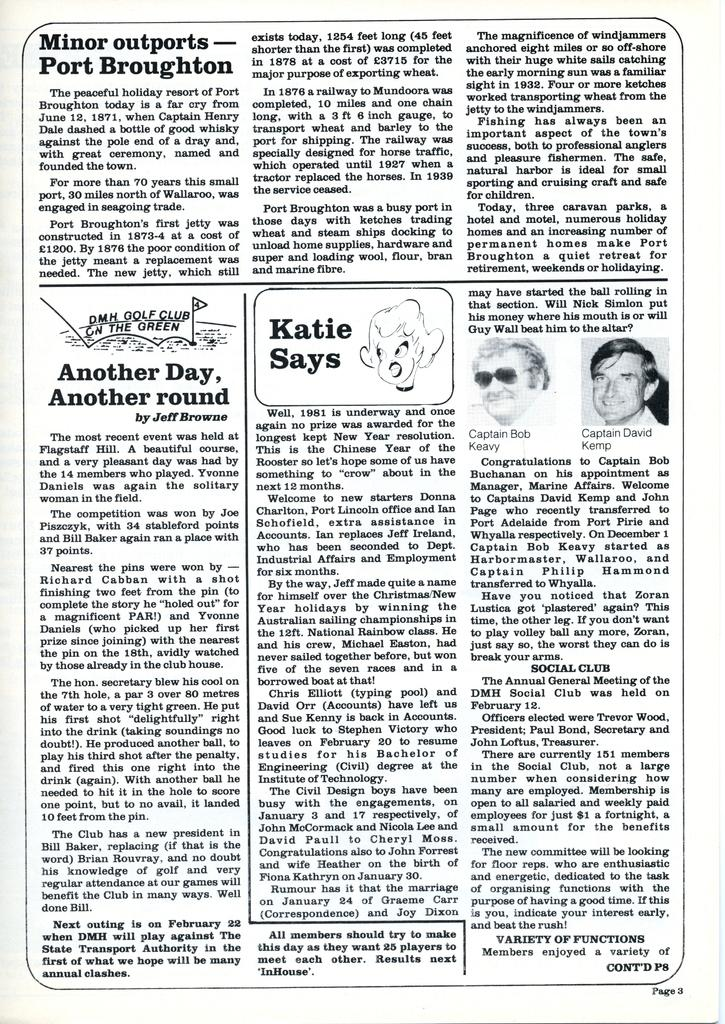What is the main subject of the image? The main subject of the image is a matter with writing on it. Can you describe the writing on the matter? Unfortunately, the facts provided do not give any information about the content of the writing. Are there any people visible in the image? Yes, there are two persons in the top right corner of the image. How many cherries are on the self in the image? There is no mention of cherries or a self in the image, so it is not possible to answer this question. 